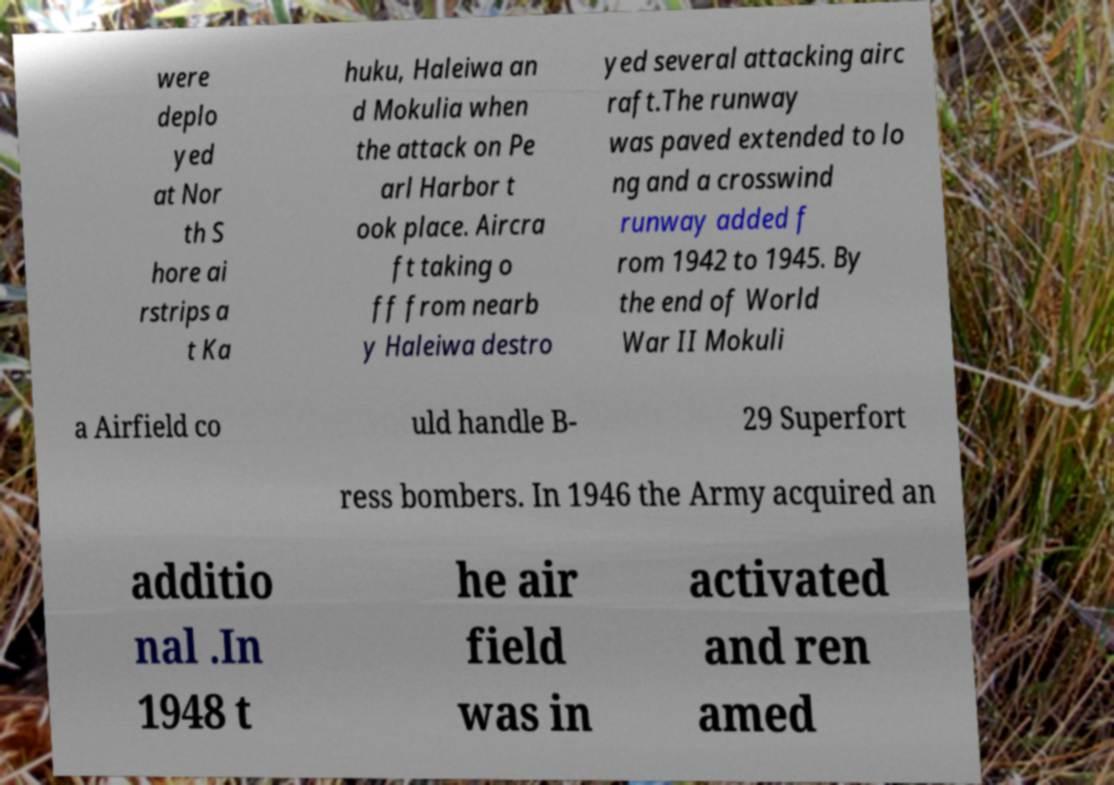Please read and relay the text visible in this image. What does it say? were deplo yed at Nor th S hore ai rstrips a t Ka huku, Haleiwa an d Mokulia when the attack on Pe arl Harbor t ook place. Aircra ft taking o ff from nearb y Haleiwa destro yed several attacking airc raft.The runway was paved extended to lo ng and a crosswind runway added f rom 1942 to 1945. By the end of World War II Mokuli a Airfield co uld handle B- 29 Superfort ress bombers. In 1946 the Army acquired an additio nal .In 1948 t he air field was in activated and ren amed 